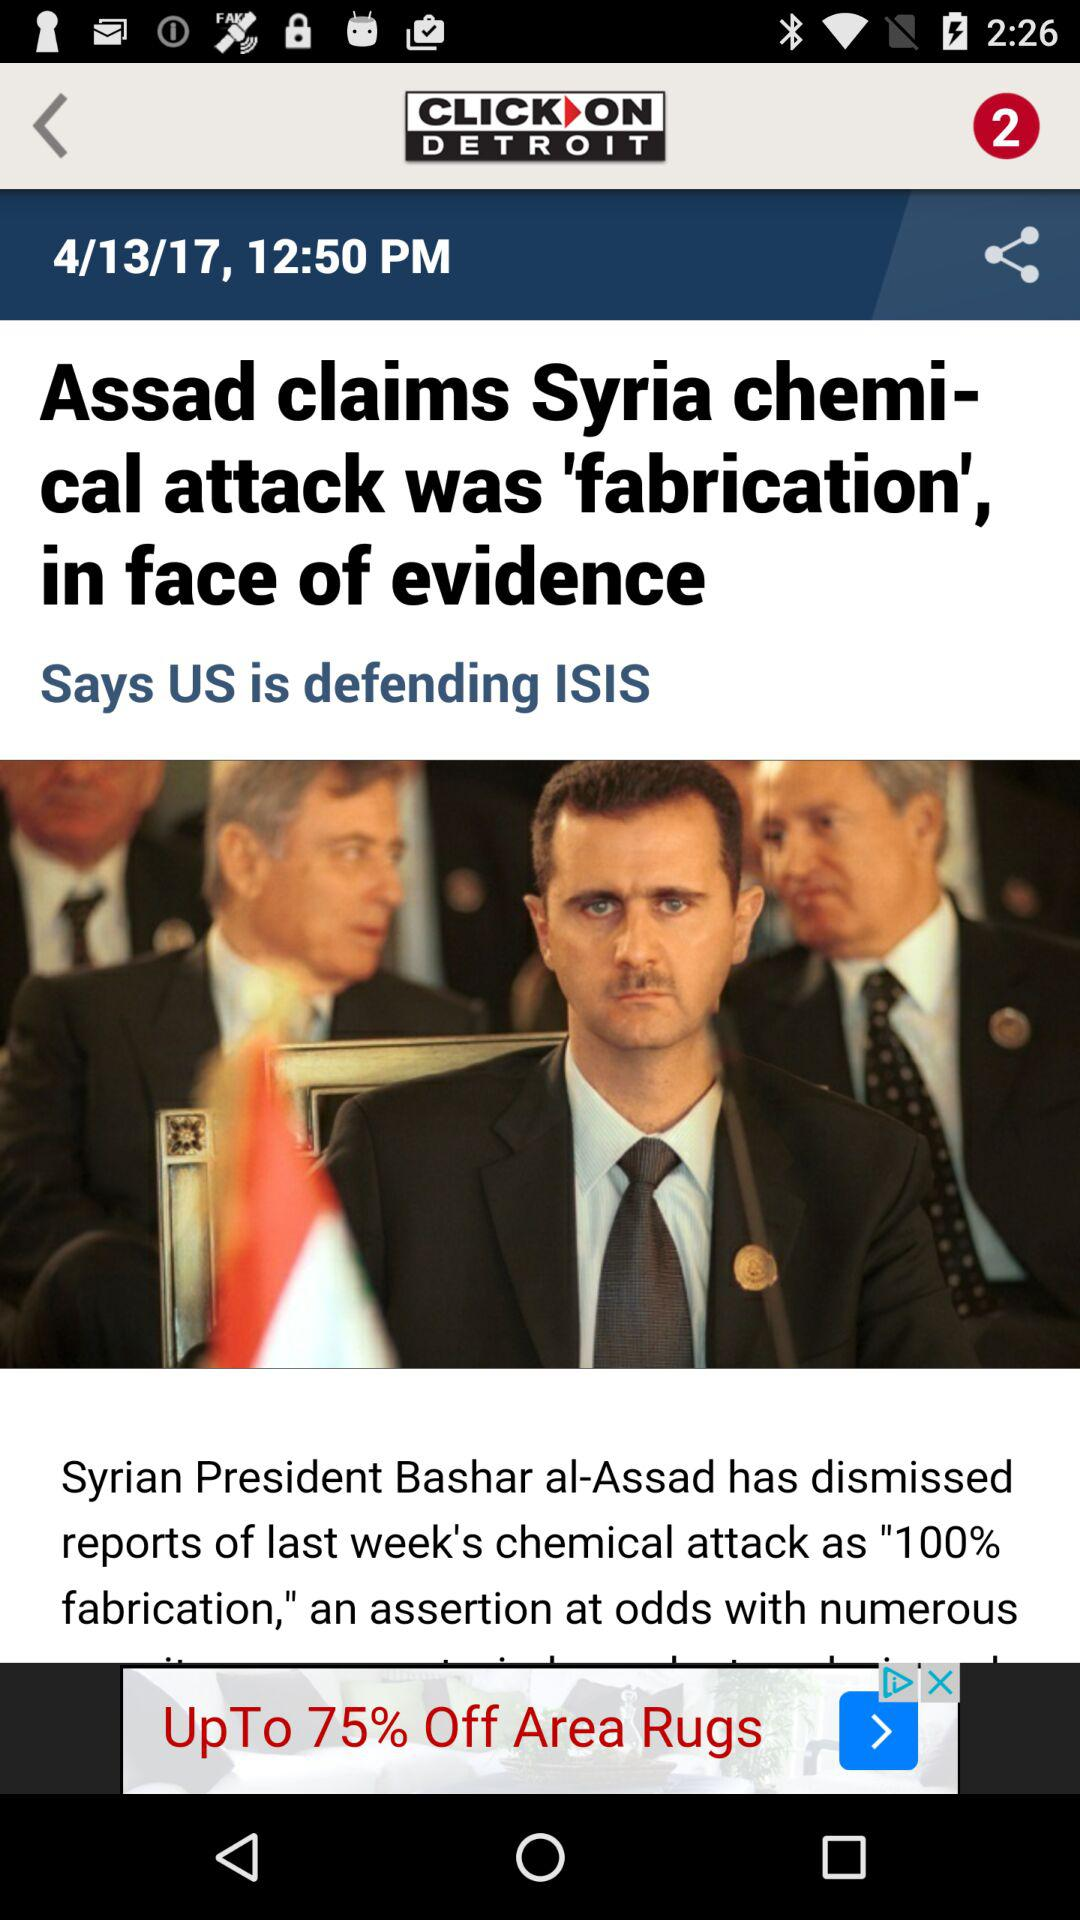What is the given date? The date is April 13, 2017. 